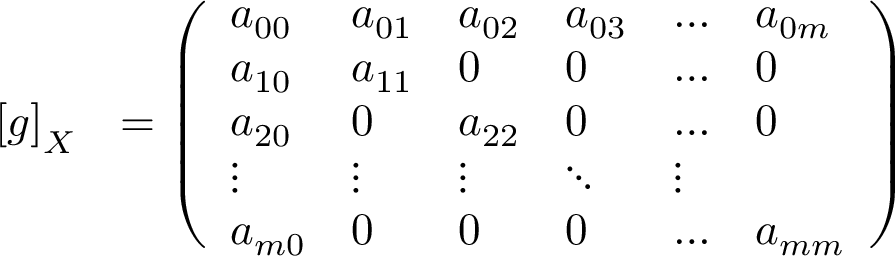<formula> <loc_0><loc_0><loc_500><loc_500>\begin{array} { r l } { \left [ g \right ] _ { X } } & { = \left ( \begin{array} { l l l l l l } { a _ { 0 0 } } & { a _ { 0 1 } } & { a _ { 0 2 } } & { a _ { 0 3 } } & { \dots } & { a _ { 0 m } } \\ { a _ { 1 0 } } & { a _ { 1 1 } } & { 0 } & { 0 } & { \dots } & { 0 } \\ { a _ { 2 0 } } & { 0 } & { a _ { 2 2 } } & { 0 } & { \dots } & { 0 } \\ { \vdots } & { \vdots } & { \vdots } & { \ddots } & { \vdots } \\ { a _ { m 0 } } & { 0 } & { 0 } & { 0 } & { \dots } & { a _ { m m } } \end{array} \right ) } \end{array}</formula> 